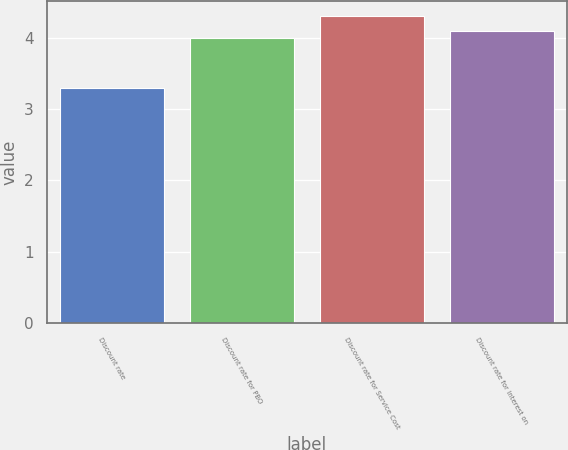Convert chart to OTSL. <chart><loc_0><loc_0><loc_500><loc_500><bar_chart><fcel>Discount rate<fcel>Discount rate for PBO<fcel>Discount rate for Service Cost<fcel>Discount rate for Interest on<nl><fcel>3.3<fcel>4<fcel>4.3<fcel>4.1<nl></chart> 